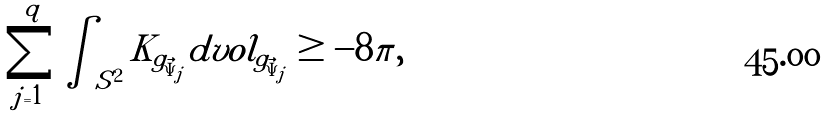<formula> <loc_0><loc_0><loc_500><loc_500>\sum _ { j = 1 } ^ { q } \int _ { S ^ { 2 } } K _ { g _ { \vec { \Psi } _ { j } } } d v o l _ { g _ { \vec { \Psi } _ { j } } } \geq - 8 \pi ,</formula> 